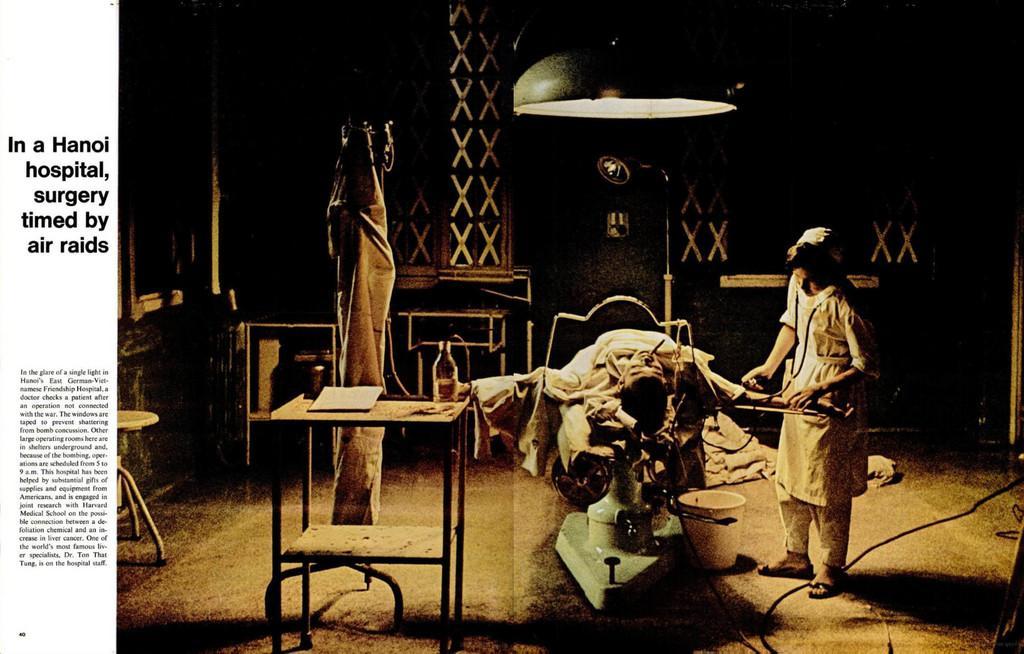Can you describe this image briefly? On the right side a person is giving treatment to this person in the middle. This person wore white color dress, at the top it is the light. 